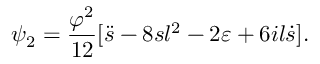<formula> <loc_0><loc_0><loc_500><loc_500>\psi _ { 2 } = \frac { \varphi ^ { 2 } } { 1 2 } [ \ddot { s } - 8 s l ^ { 2 } - 2 \varepsilon + 6 i l \dot { s } ] .</formula> 